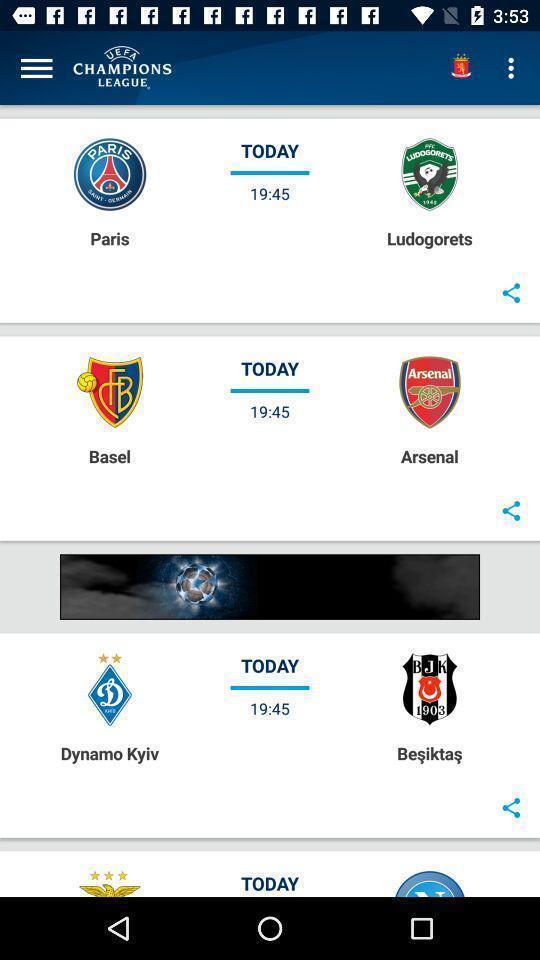Give me a narrative description of this picture. Page displaying the timings of matches. 